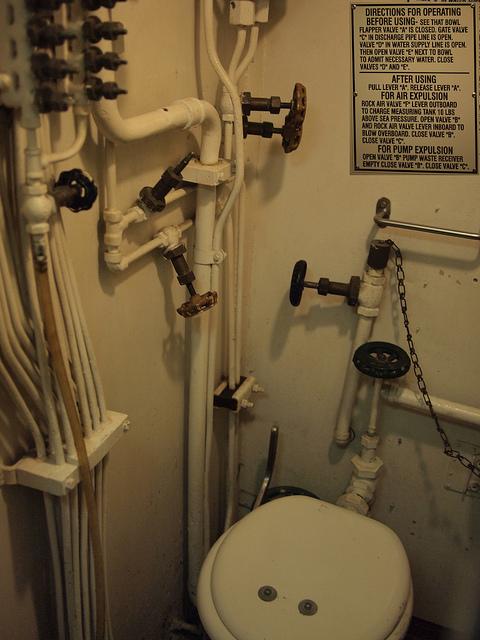Would it be dangerous to use this toilet?
Answer briefly. Yes. What color is the hose on the left of the picture?
Answer briefly. Yellow. What room is this?
Be succinct. Bathroom. Is this bathroom in someone's home?
Answer briefly. No. 